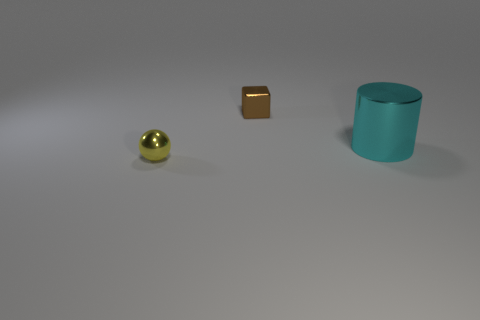Add 3 tiny yellow balls. How many objects exist? 6 Subtract 1 balls. How many balls are left? 0 Subtract all cylinders. How many objects are left? 2 Add 3 large cylinders. How many large cylinders are left? 4 Add 3 brown metal cubes. How many brown metal cubes exist? 4 Subtract 1 brown cubes. How many objects are left? 2 Subtract all gray balls. Subtract all red blocks. How many balls are left? 1 Subtract all large purple matte objects. Subtract all small brown objects. How many objects are left? 2 